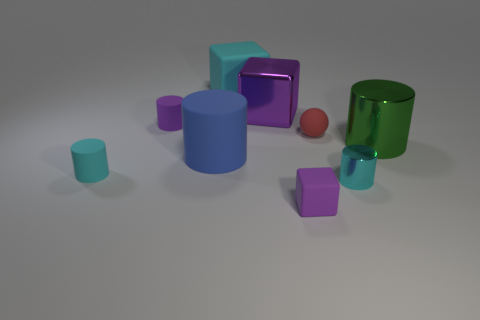Subtract all metallic cylinders. How many cylinders are left? 3 Add 1 cyan metal cylinders. How many objects exist? 10 Subtract all cyan blocks. How many blocks are left? 2 Subtract all red spheres. How many cyan cylinders are left? 2 Subtract 1 cubes. How many cubes are left? 2 Subtract all balls. How many objects are left? 8 Add 7 small matte cylinders. How many small matte cylinders are left? 9 Add 7 tiny metal cylinders. How many tiny metal cylinders exist? 8 Subtract 0 yellow cylinders. How many objects are left? 9 Subtract all blue cubes. Subtract all brown cylinders. How many cubes are left? 3 